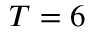<formula> <loc_0><loc_0><loc_500><loc_500>T = 6</formula> 